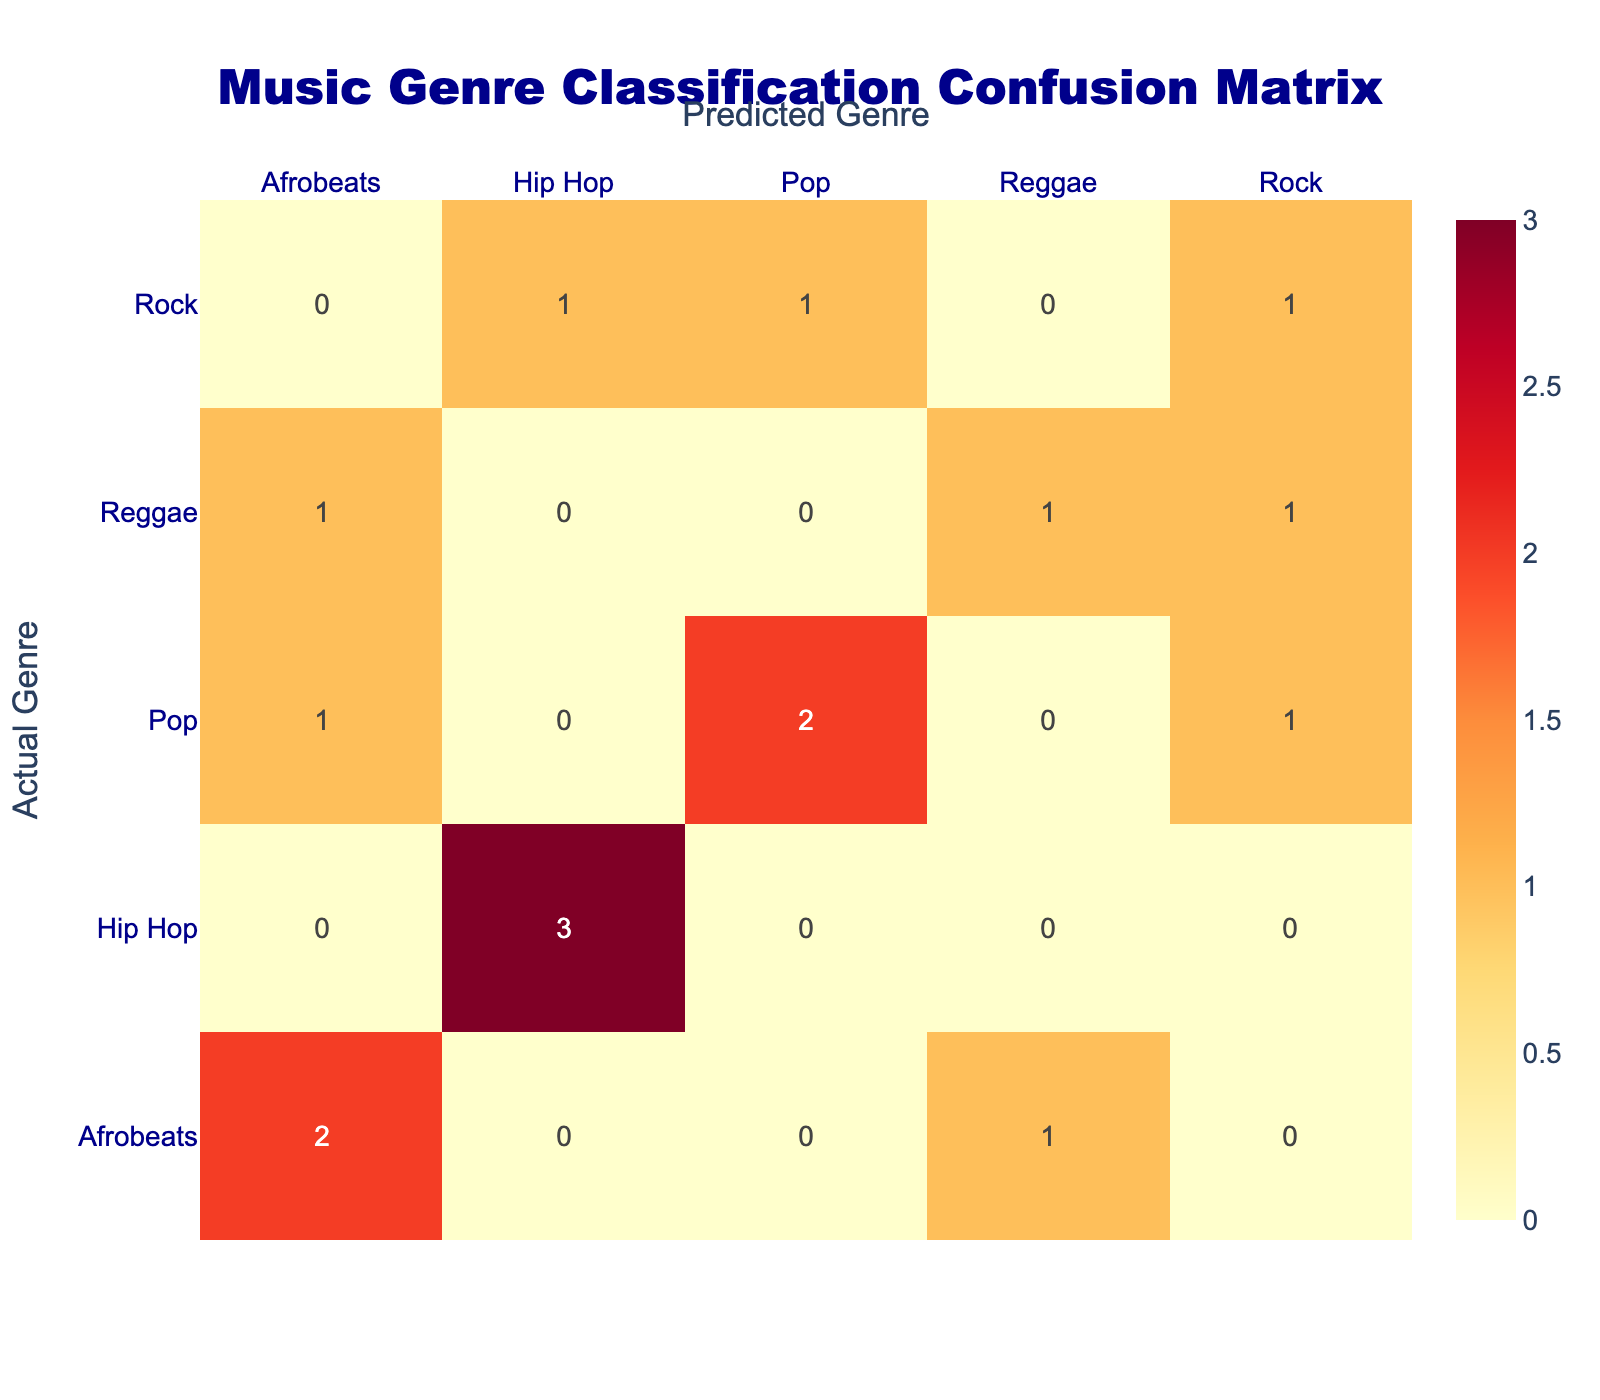What is the total number of students who had their genre correctly predicted? The correctly predicted genres are along the diagonal of the confusion matrix: Afrobeats, Hip Hop, Reggae, Pop, and Rock. Counting these gives us: 5 students (Amina, Chijioke, Kemi, Obinna, and Chinwe).
Answer: 5 How many students had their genre predicted as Reggae? We can look at the Reggae column in the confusion matrix. It shows that 2 students (Emeka and Tariq) were predicted to be Reggae.
Answer: 2 Is there any genre that had no correct predictions? By examining the diagonal of the confusion matrix, we see that Rock had a total of 2 students predicted (Chinonso and Zainab), but only Chinwe is correctly predicted, thus confirming no one was incorrectly predicted for Pop. Therefore, Hip Hop didn’t have any wrong predictions, and others have their predictions fulfilled.
Answer: Yes What is the total number of students who preferred Afrobeats but were predicted as a different genre? Looking at the Afrobeats row, we see that only Doyin was listed as Reggae instead of Afrobeats. So there is 1 student.
Answer: 1 Which genre had the most misclassifications? We can find misunderstandings by checking rows against columns. The misclassification counts can be summed for each genre: 1 for Reggae (Predicted as Afrobeats), 1 for Rock (Predicted as Pop), and 2 for Afrobeats (Predicted as Reggae) indicates that Rock had a mispredicted number of students totaling 3.
Answer: Afrobeats What percentage of students who liked Pop had their genre correctly predicted? The students who liked Pop are Fatima, Khalid, and Ifeoma. Out of these, Fatima was incorrectly predicted as Rock, while Khalid and Ifeoma were correctly predicted. So that's 2 out of 3, leading to (2/3)*100 = 66.67 %.
Answer: 66.67 % How many students preferred Rock, and what were their prediction outcomes? By reviewing the Rock row, there are 3 Rock preferences: Chinonso (predicted as Hip Hop), Zainab (predicted as Pop), and Chinwe (predicted as Rock). This results in 3 students whose prediction outcomes were not aligned with their actual choices.
Answer: 3 students What is the ratio of correct predictions of Hip Hop to total predictions made for Hip Hop? The only students who preferred Hip Hop are Chijioke and Ngozi, both of whom were correctly predicted. Thus, the ratio of correct predictions (2) to total predictions (2) is 2:2, or simplified to 1:1.
Answer: 1:1 What is the most common genre predicted incorrectly? Similar to previous misclassification assessments, if we examine the sum of misclassifications across genres, we find that Afrobeats had the highest score against predicted Reggae totaling 3 instances.
Answer: Afrobeats 